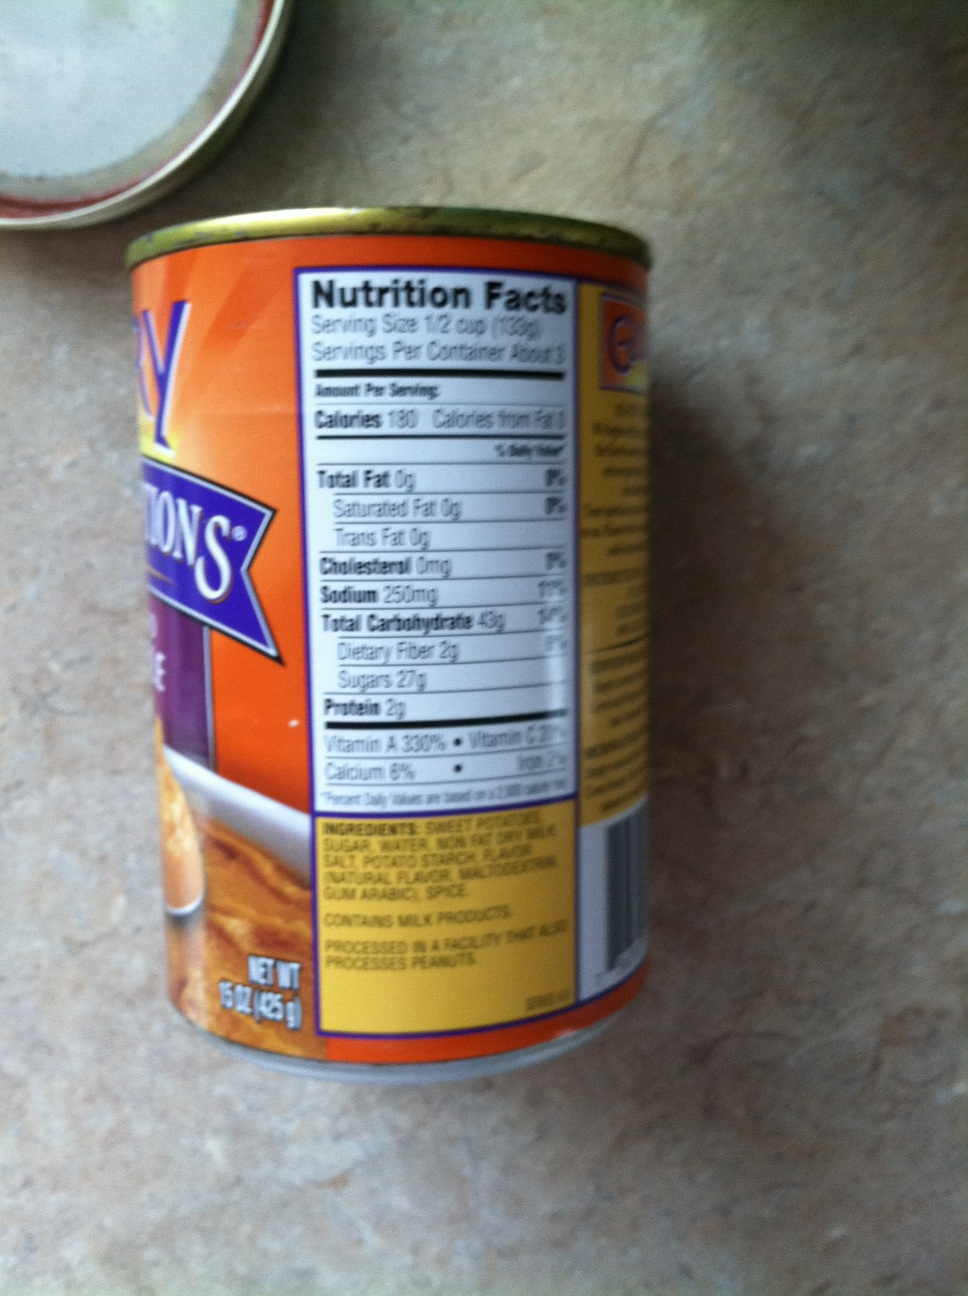Can you explain the nutritional information on this tin? Sure! The nutritional label on this tin provides information about the contents. Each serving size is 1/2 cup (130g), and there are about 3 servings per container. Each serving provides 130 calories, with 0g of total fat, 0g of cholesterol, 250mg of sodium, 43g of carbohydrates (including 2g of dietary fiber and 27g of sugar), and 2g of protein. The label also highlights that the product is a good source of Vitamin A (330% daily value) and Vitamin C (15% daily value). 